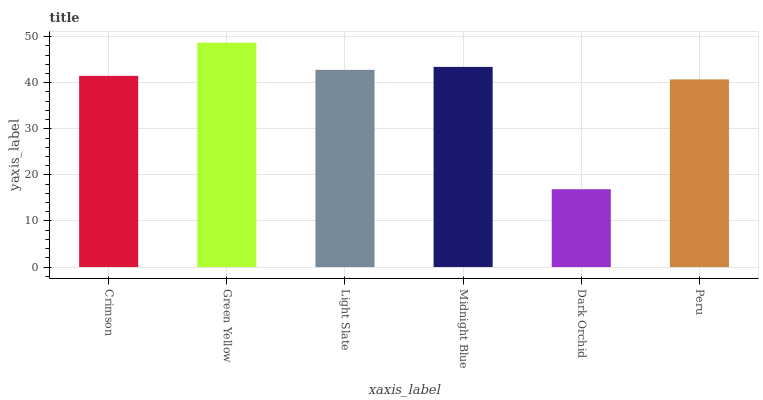Is Dark Orchid the minimum?
Answer yes or no. Yes. Is Green Yellow the maximum?
Answer yes or no. Yes. Is Light Slate the minimum?
Answer yes or no. No. Is Light Slate the maximum?
Answer yes or no. No. Is Green Yellow greater than Light Slate?
Answer yes or no. Yes. Is Light Slate less than Green Yellow?
Answer yes or no. Yes. Is Light Slate greater than Green Yellow?
Answer yes or no. No. Is Green Yellow less than Light Slate?
Answer yes or no. No. Is Light Slate the high median?
Answer yes or no. Yes. Is Crimson the low median?
Answer yes or no. Yes. Is Peru the high median?
Answer yes or no. No. Is Peru the low median?
Answer yes or no. No. 